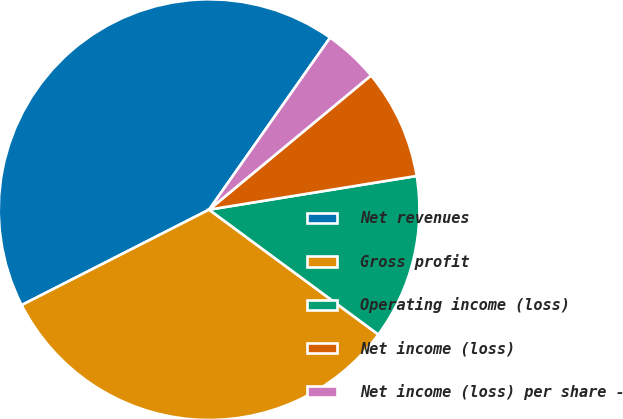Convert chart. <chart><loc_0><loc_0><loc_500><loc_500><pie_chart><fcel>Net revenues<fcel>Gross profit<fcel>Operating income (loss)<fcel>Net income (loss)<fcel>Net income (loss) per share -<nl><fcel>42.26%<fcel>32.39%<fcel>12.68%<fcel>8.45%<fcel>4.23%<nl></chart> 